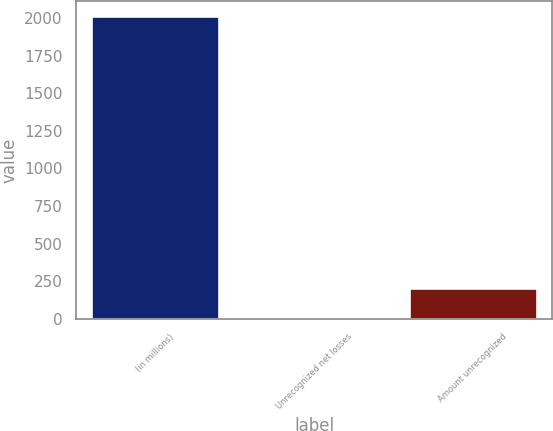Convert chart. <chart><loc_0><loc_0><loc_500><loc_500><bar_chart><fcel>(in millions)<fcel>Unrecognized net losses<fcel>Amount unrecognized<nl><fcel>2011<fcel>6<fcel>206.5<nl></chart> 